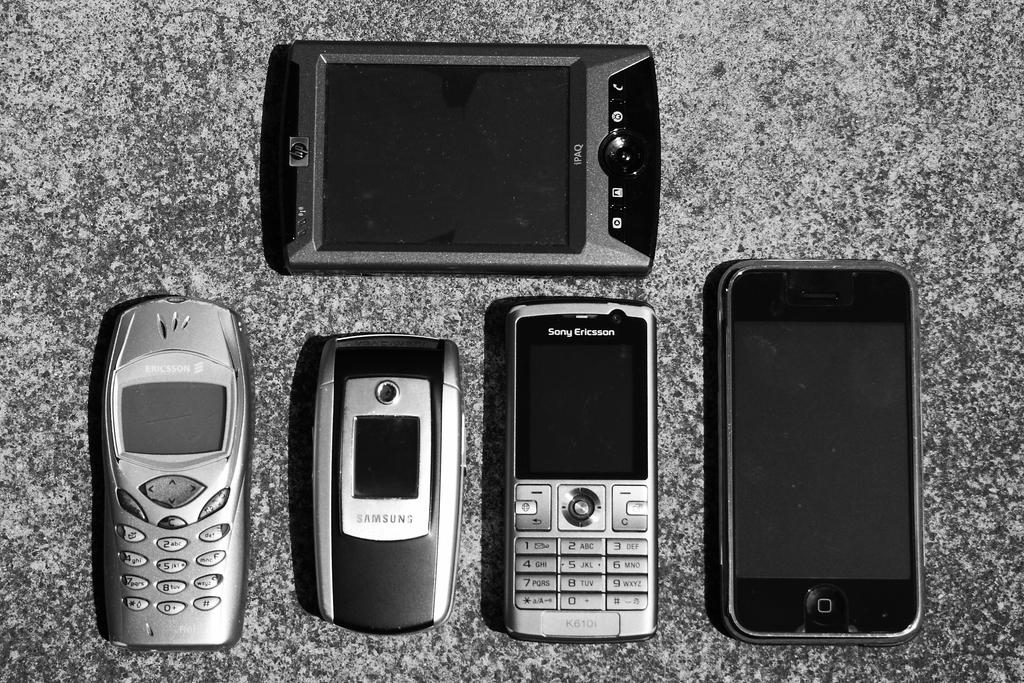What electronic devices are present in the image? There are mobile phones in the image. Where are the mobile phones located? The mobile phones are on a table. What advice does the mother give to her child in the alley in the image? There is no mother, child, or alley present in the image; it only features mobile phones on a table. 